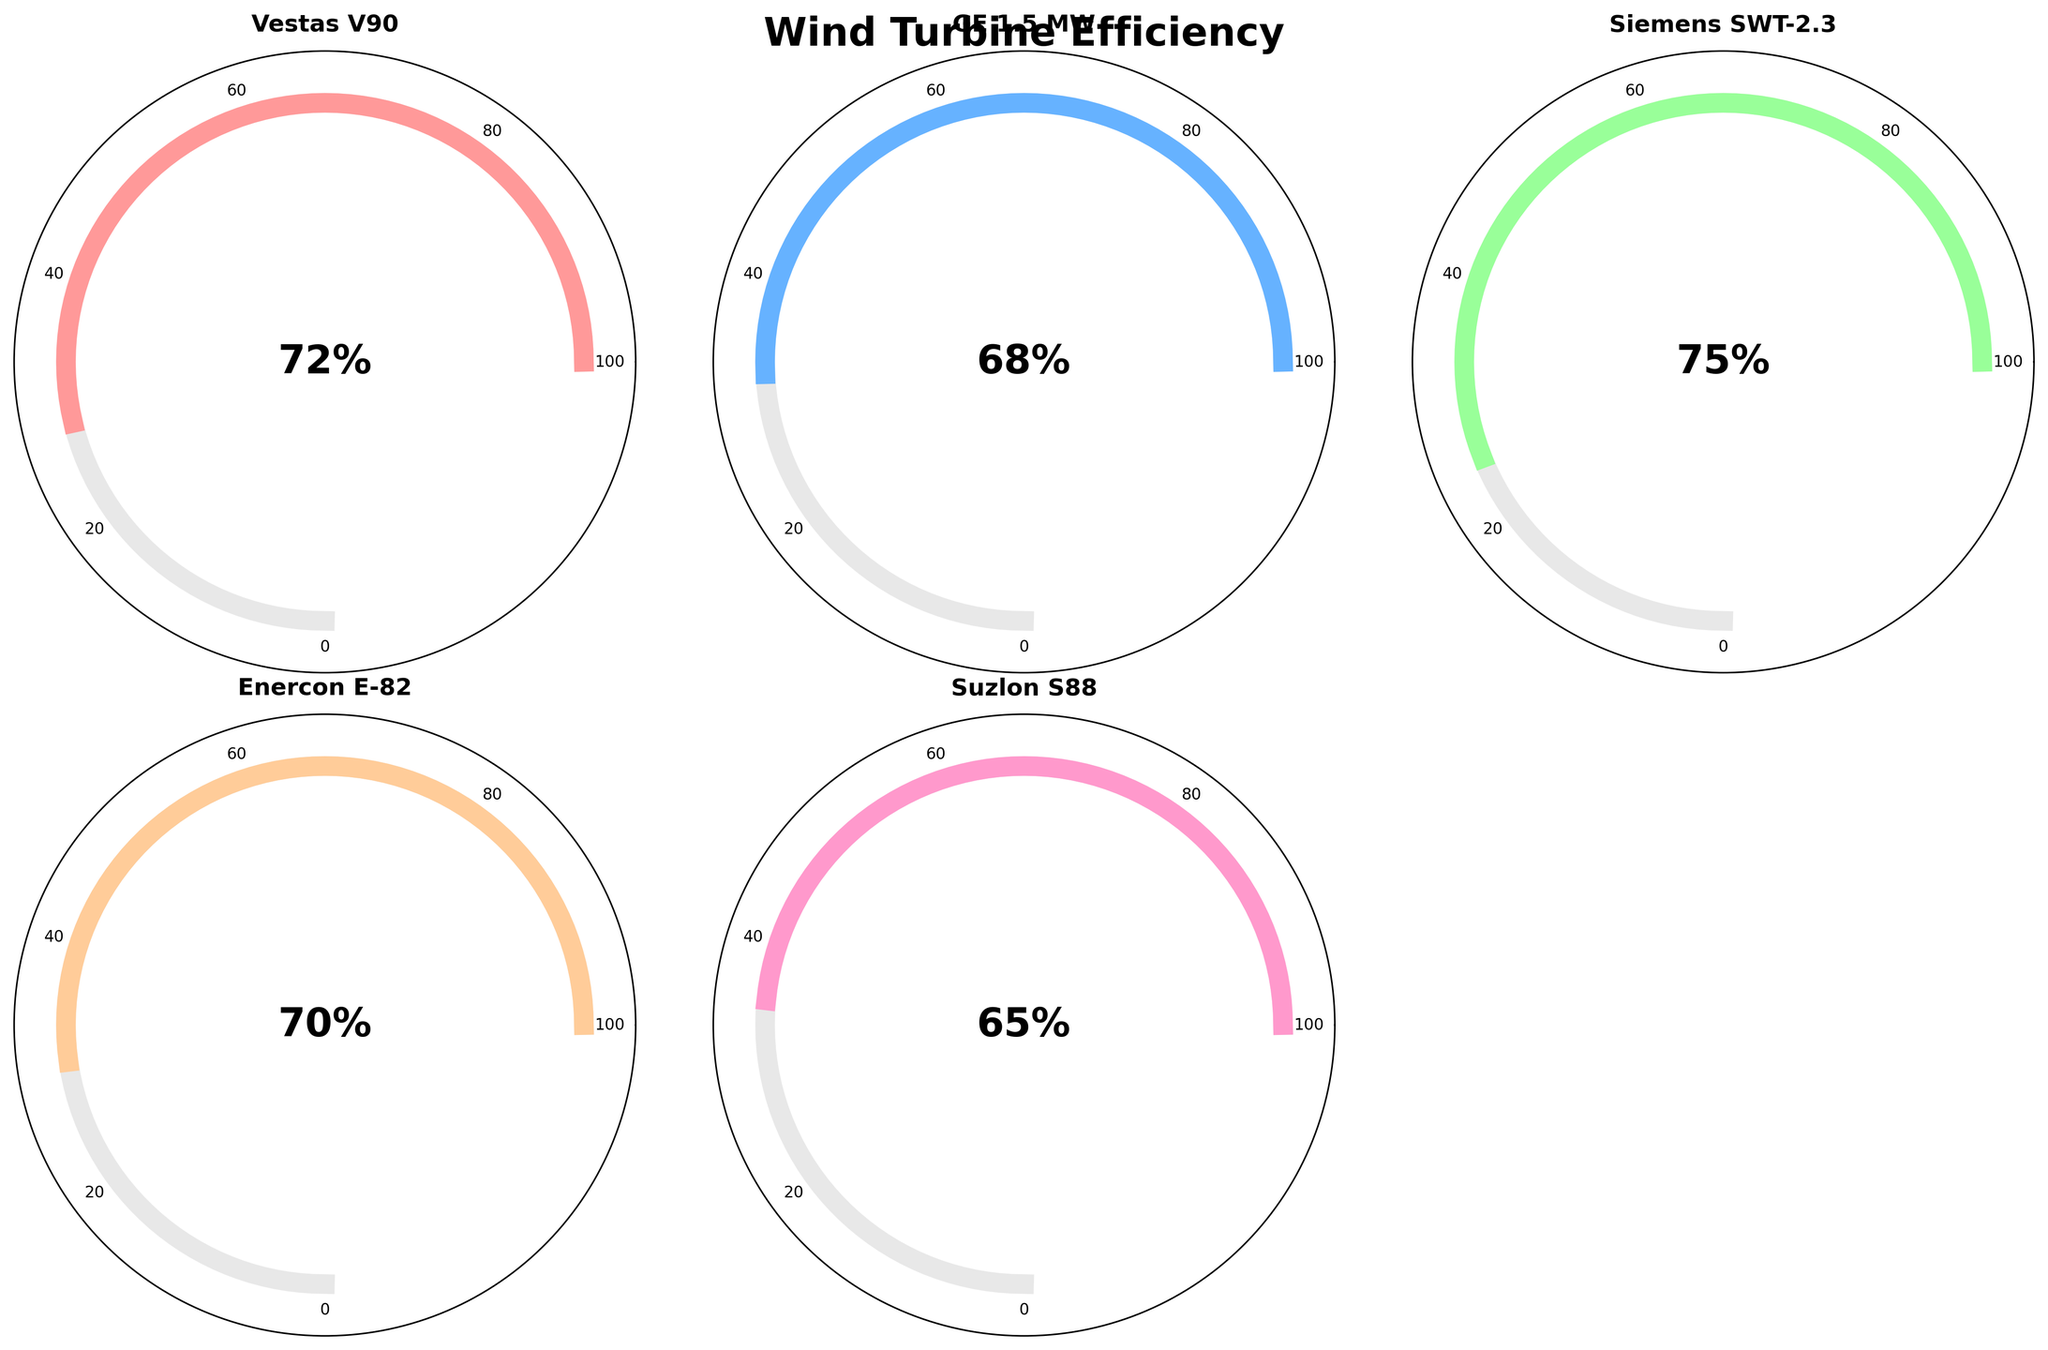Which wind turbine has the highest efficiency? Scan the efficiency percentages on the gauge charts and find the highest one. Siemens SWT-2.3 has an efficiency of 75%, which is the highest.
Answer: Siemens SWT-2.3 What is the efficiency percentage of the GE 1.5 MW turbine? Look at the gauge chart for the GE 1.5 MW turbine. The efficiency percentage displayed in the center is 68%.
Answer: 68% How many wind turbines have an efficiency of 70% or higher? Identify the turbines with efficiency percentages 70% or higher: Vestas V90 (72%), Siemens SWT-2.3 (75%), and Enercon E-82 (70%). Count them.
Answer: 3 Which turbine is performing the worst in terms of efficiency? Scan the efficiency percentages and find the lowest one. Suzlon S88 has the lowest efficiency at 65%.
Answer: Suzlon S88 Calculate the average efficiency of all the turbines. Add up all the efficiency percentages: 72 + 68 + 75 + 70 + 65 = 350. Then divide by the number of turbines (5). The average efficiency is 350/5 = 70%.
Answer: 70% How does the efficiency of the Enercon E-82 compare to the GE 1.5 MW? The Enercon E-82 has an efficiency of 70%, while the GE 1.5 MW has an efficiency of 68%. Compare these two percentages.
Answer: Enercon E-82 is 2% higher What is the sum of the efficiency percentages of the Vestas V90 and Siemens SWT-2.3 turbines? Add the efficiency percentages of Vestas V90 (72%) and Siemens SWT-2.3 (75%). The sum is 72 + 75 = 147.
Answer: 147 Identify the color used for the Vestas V90 turbine's gauge chart. Look at the fill color on the gauge representing the Vestas V90 turbine. The color is a shade of red.
Answer: Red Among the displayed turbines, which has an efficiency closest to 70%? Identify the efficiencies closest to 70%: Enercon E-82 with 70% and GE 1.5 MW with 68%. Relatively, Enercon E-82 is exactly 70%.
Answer: Enercon E-82 Based on the gauge charts, which turbine lies in the middle of the efficiency range? Arrange the turbines by their efficiencies and find the middle value: Suzlon S88 (65%), GE 1.5 MW (68%), Enercon E-82 (70%), Vestas V90 (72%), Siemens SWT-2.3 (75%). The median value is GE 1.5 MW at 68%.
Answer: GE 1.5 MW 